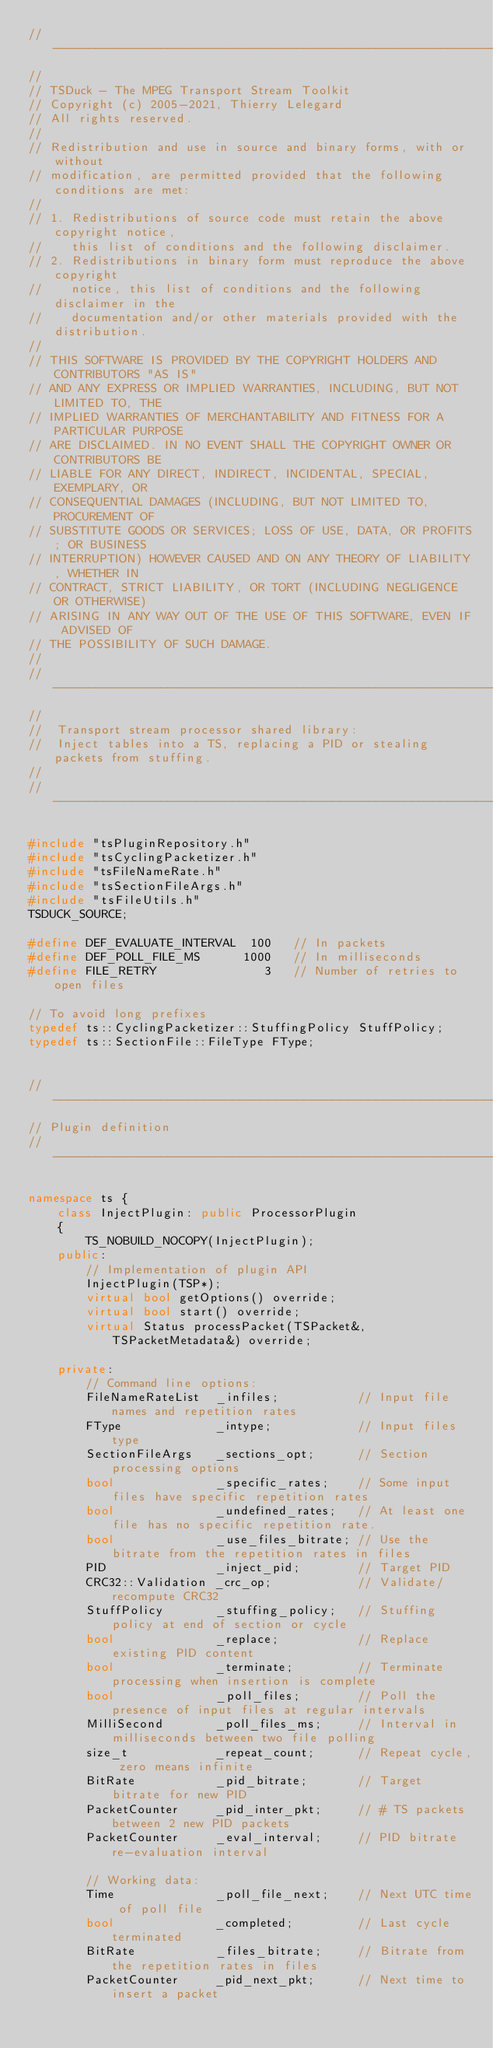Convert code to text. <code><loc_0><loc_0><loc_500><loc_500><_C++_>//----------------------------------------------------------------------------
//
// TSDuck - The MPEG Transport Stream Toolkit
// Copyright (c) 2005-2021, Thierry Lelegard
// All rights reserved.
//
// Redistribution and use in source and binary forms, with or without
// modification, are permitted provided that the following conditions are met:
//
// 1. Redistributions of source code must retain the above copyright notice,
//    this list of conditions and the following disclaimer.
// 2. Redistributions in binary form must reproduce the above copyright
//    notice, this list of conditions and the following disclaimer in the
//    documentation and/or other materials provided with the distribution.
//
// THIS SOFTWARE IS PROVIDED BY THE COPYRIGHT HOLDERS AND CONTRIBUTORS "AS IS"
// AND ANY EXPRESS OR IMPLIED WARRANTIES, INCLUDING, BUT NOT LIMITED TO, THE
// IMPLIED WARRANTIES OF MERCHANTABILITY AND FITNESS FOR A PARTICULAR PURPOSE
// ARE DISCLAIMED. IN NO EVENT SHALL THE COPYRIGHT OWNER OR CONTRIBUTORS BE
// LIABLE FOR ANY DIRECT, INDIRECT, INCIDENTAL, SPECIAL, EXEMPLARY, OR
// CONSEQUENTIAL DAMAGES (INCLUDING, BUT NOT LIMITED TO, PROCUREMENT OF
// SUBSTITUTE GOODS OR SERVICES; LOSS OF USE, DATA, OR PROFITS; OR BUSINESS
// INTERRUPTION) HOWEVER CAUSED AND ON ANY THEORY OF LIABILITY, WHETHER IN
// CONTRACT, STRICT LIABILITY, OR TORT (INCLUDING NEGLIGENCE OR OTHERWISE)
// ARISING IN ANY WAY OUT OF THE USE OF THIS SOFTWARE, EVEN IF ADVISED OF
// THE POSSIBILITY OF SUCH DAMAGE.
//
//----------------------------------------------------------------------------
//
//  Transport stream processor shared library:
//  Inject tables into a TS, replacing a PID or stealing packets from stuffing.
//
//----------------------------------------------------------------------------

#include "tsPluginRepository.h"
#include "tsCyclingPacketizer.h"
#include "tsFileNameRate.h"
#include "tsSectionFileArgs.h"
#include "tsFileUtils.h"
TSDUCK_SOURCE;

#define DEF_EVALUATE_INTERVAL  100   // In packets
#define DEF_POLL_FILE_MS      1000   // In milliseconds
#define FILE_RETRY               3   // Number of retries to open files

// To avoid long prefixes
typedef ts::CyclingPacketizer::StuffingPolicy StuffPolicy;
typedef ts::SectionFile::FileType FType;


//----------------------------------------------------------------------------
// Plugin definition
//----------------------------------------------------------------------------

namespace ts {
    class InjectPlugin: public ProcessorPlugin
    {
        TS_NOBUILD_NOCOPY(InjectPlugin);
    public:
        // Implementation of plugin API
        InjectPlugin(TSP*);
        virtual bool getOptions() override;
        virtual bool start() override;
        virtual Status processPacket(TSPacket&, TSPacketMetadata&) override;

    private:
        // Command line options:
        FileNameRateList  _infiles;           // Input file names and repetition rates
        FType             _intype;            // Input files type
        SectionFileArgs   _sections_opt;      // Section processing options
        bool              _specific_rates;    // Some input files have specific repetition rates
        bool              _undefined_rates;   // At least one file has no specific repetition rate.
        bool              _use_files_bitrate; // Use the bitrate from the repetition rates in files
        PID               _inject_pid;        // Target PID
        CRC32::Validation _crc_op;            // Validate/recompute CRC32
        StuffPolicy       _stuffing_policy;   // Stuffing policy at end of section or cycle
        bool              _replace;           // Replace existing PID content
        bool              _terminate;         // Terminate processing when insertion is complete
        bool              _poll_files;        // Poll the presence of input files at regular intervals
        MilliSecond       _poll_files_ms;     // Interval in milliseconds between two file polling
        size_t            _repeat_count;      // Repeat cycle, zero means infinite
        BitRate           _pid_bitrate;       // Target bitrate for new PID
        PacketCounter     _pid_inter_pkt;     // # TS packets between 2 new PID packets
        PacketCounter     _eval_interval;     // PID bitrate re-evaluation interval

        // Working data:
        Time              _poll_file_next;    // Next UTC time of poll file
        bool              _completed;         // Last cycle terminated
        BitRate           _files_bitrate;     // Bitrate from the repetition rates in files
        PacketCounter     _pid_next_pkt;      // Next time to insert a packet</code> 